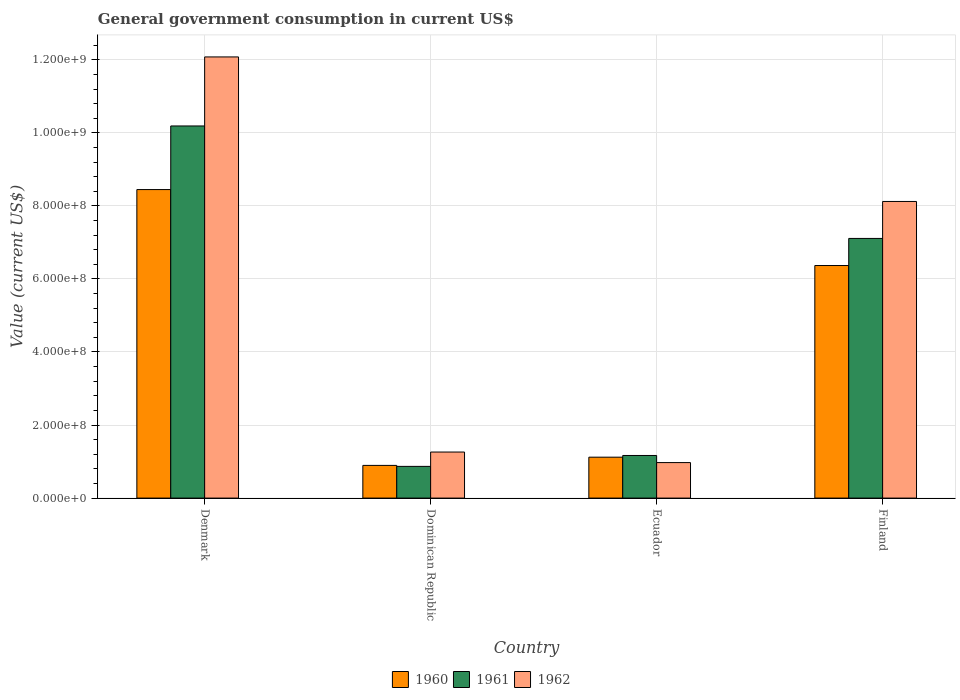How many groups of bars are there?
Your answer should be compact. 4. Are the number of bars on each tick of the X-axis equal?
Your response must be concise. Yes. What is the label of the 1st group of bars from the left?
Make the answer very short. Denmark. In how many cases, is the number of bars for a given country not equal to the number of legend labels?
Make the answer very short. 0. What is the government conusmption in 1960 in Finland?
Make the answer very short. 6.37e+08. Across all countries, what is the maximum government conusmption in 1961?
Ensure brevity in your answer.  1.02e+09. Across all countries, what is the minimum government conusmption in 1960?
Your response must be concise. 8.95e+07. In which country was the government conusmption in 1960 maximum?
Offer a very short reply. Denmark. In which country was the government conusmption in 1960 minimum?
Offer a terse response. Dominican Republic. What is the total government conusmption in 1960 in the graph?
Your answer should be very brief. 1.68e+09. What is the difference between the government conusmption in 1960 in Dominican Republic and that in Finland?
Offer a terse response. -5.47e+08. What is the difference between the government conusmption in 1961 in Ecuador and the government conusmption in 1962 in Dominican Republic?
Give a very brief answer. -9.42e+06. What is the average government conusmption in 1961 per country?
Your answer should be very brief. 4.83e+08. What is the difference between the government conusmption of/in 1960 and government conusmption of/in 1961 in Ecuador?
Give a very brief answer. -4.67e+06. What is the ratio of the government conusmption in 1962 in Denmark to that in Finland?
Make the answer very short. 1.49. Is the government conusmption in 1961 in Denmark less than that in Finland?
Ensure brevity in your answer.  No. What is the difference between the highest and the second highest government conusmption in 1961?
Offer a very short reply. -9.02e+08. What is the difference between the highest and the lowest government conusmption in 1961?
Your answer should be compact. 9.32e+08. In how many countries, is the government conusmption in 1962 greater than the average government conusmption in 1962 taken over all countries?
Your answer should be very brief. 2. Is the sum of the government conusmption in 1960 in Dominican Republic and Finland greater than the maximum government conusmption in 1962 across all countries?
Keep it short and to the point. No. What does the 1st bar from the right in Dominican Republic represents?
Your answer should be very brief. 1962. Is it the case that in every country, the sum of the government conusmption in 1962 and government conusmption in 1961 is greater than the government conusmption in 1960?
Ensure brevity in your answer.  Yes. How many bars are there?
Ensure brevity in your answer.  12. Are all the bars in the graph horizontal?
Provide a short and direct response. No. Does the graph contain any zero values?
Your answer should be compact. No. What is the title of the graph?
Offer a very short reply. General government consumption in current US$. What is the label or title of the X-axis?
Offer a terse response. Country. What is the label or title of the Y-axis?
Offer a terse response. Value (current US$). What is the Value (current US$) of 1960 in Denmark?
Offer a terse response. 8.45e+08. What is the Value (current US$) of 1961 in Denmark?
Make the answer very short. 1.02e+09. What is the Value (current US$) in 1962 in Denmark?
Make the answer very short. 1.21e+09. What is the Value (current US$) of 1960 in Dominican Republic?
Your answer should be very brief. 8.95e+07. What is the Value (current US$) of 1961 in Dominican Republic?
Your answer should be very brief. 8.68e+07. What is the Value (current US$) of 1962 in Dominican Republic?
Provide a succinct answer. 1.26e+08. What is the Value (current US$) in 1960 in Ecuador?
Provide a short and direct response. 1.12e+08. What is the Value (current US$) of 1961 in Ecuador?
Provide a succinct answer. 1.17e+08. What is the Value (current US$) of 1962 in Ecuador?
Make the answer very short. 9.72e+07. What is the Value (current US$) in 1960 in Finland?
Your answer should be very brief. 6.37e+08. What is the Value (current US$) of 1961 in Finland?
Your response must be concise. 7.11e+08. What is the Value (current US$) in 1962 in Finland?
Keep it short and to the point. 8.12e+08. Across all countries, what is the maximum Value (current US$) of 1960?
Make the answer very short. 8.45e+08. Across all countries, what is the maximum Value (current US$) in 1961?
Make the answer very short. 1.02e+09. Across all countries, what is the maximum Value (current US$) in 1962?
Your response must be concise. 1.21e+09. Across all countries, what is the minimum Value (current US$) of 1960?
Give a very brief answer. 8.95e+07. Across all countries, what is the minimum Value (current US$) of 1961?
Provide a short and direct response. 8.68e+07. Across all countries, what is the minimum Value (current US$) of 1962?
Offer a terse response. 9.72e+07. What is the total Value (current US$) in 1960 in the graph?
Ensure brevity in your answer.  1.68e+09. What is the total Value (current US$) in 1961 in the graph?
Your answer should be compact. 1.93e+09. What is the total Value (current US$) of 1962 in the graph?
Offer a very short reply. 2.24e+09. What is the difference between the Value (current US$) in 1960 in Denmark and that in Dominican Republic?
Keep it short and to the point. 7.55e+08. What is the difference between the Value (current US$) in 1961 in Denmark and that in Dominican Republic?
Provide a succinct answer. 9.32e+08. What is the difference between the Value (current US$) of 1962 in Denmark and that in Dominican Republic?
Provide a short and direct response. 1.08e+09. What is the difference between the Value (current US$) of 1960 in Denmark and that in Ecuador?
Make the answer very short. 7.33e+08. What is the difference between the Value (current US$) of 1961 in Denmark and that in Ecuador?
Your answer should be compact. 9.02e+08. What is the difference between the Value (current US$) in 1962 in Denmark and that in Ecuador?
Provide a short and direct response. 1.11e+09. What is the difference between the Value (current US$) in 1960 in Denmark and that in Finland?
Offer a terse response. 2.08e+08. What is the difference between the Value (current US$) in 1961 in Denmark and that in Finland?
Ensure brevity in your answer.  3.08e+08. What is the difference between the Value (current US$) of 1962 in Denmark and that in Finland?
Offer a very short reply. 3.96e+08. What is the difference between the Value (current US$) of 1960 in Dominican Republic and that in Ecuador?
Keep it short and to the point. -2.25e+07. What is the difference between the Value (current US$) of 1961 in Dominican Republic and that in Ecuador?
Keep it short and to the point. -2.99e+07. What is the difference between the Value (current US$) of 1962 in Dominican Republic and that in Ecuador?
Make the answer very short. 2.89e+07. What is the difference between the Value (current US$) of 1960 in Dominican Republic and that in Finland?
Give a very brief answer. -5.47e+08. What is the difference between the Value (current US$) of 1961 in Dominican Republic and that in Finland?
Make the answer very short. -6.24e+08. What is the difference between the Value (current US$) in 1962 in Dominican Republic and that in Finland?
Offer a terse response. -6.86e+08. What is the difference between the Value (current US$) in 1960 in Ecuador and that in Finland?
Provide a short and direct response. -5.25e+08. What is the difference between the Value (current US$) in 1961 in Ecuador and that in Finland?
Provide a short and direct response. -5.94e+08. What is the difference between the Value (current US$) in 1962 in Ecuador and that in Finland?
Keep it short and to the point. -7.15e+08. What is the difference between the Value (current US$) in 1960 in Denmark and the Value (current US$) in 1961 in Dominican Republic?
Keep it short and to the point. 7.58e+08. What is the difference between the Value (current US$) in 1960 in Denmark and the Value (current US$) in 1962 in Dominican Republic?
Your answer should be compact. 7.19e+08. What is the difference between the Value (current US$) in 1961 in Denmark and the Value (current US$) in 1962 in Dominican Republic?
Give a very brief answer. 8.93e+08. What is the difference between the Value (current US$) of 1960 in Denmark and the Value (current US$) of 1961 in Ecuador?
Provide a short and direct response. 7.28e+08. What is the difference between the Value (current US$) of 1960 in Denmark and the Value (current US$) of 1962 in Ecuador?
Keep it short and to the point. 7.47e+08. What is the difference between the Value (current US$) of 1961 in Denmark and the Value (current US$) of 1962 in Ecuador?
Your response must be concise. 9.22e+08. What is the difference between the Value (current US$) in 1960 in Denmark and the Value (current US$) in 1961 in Finland?
Keep it short and to the point. 1.34e+08. What is the difference between the Value (current US$) of 1960 in Denmark and the Value (current US$) of 1962 in Finland?
Ensure brevity in your answer.  3.25e+07. What is the difference between the Value (current US$) of 1961 in Denmark and the Value (current US$) of 1962 in Finland?
Your answer should be compact. 2.07e+08. What is the difference between the Value (current US$) of 1960 in Dominican Republic and the Value (current US$) of 1961 in Ecuador?
Ensure brevity in your answer.  -2.72e+07. What is the difference between the Value (current US$) of 1960 in Dominican Republic and the Value (current US$) of 1962 in Ecuador?
Your response must be concise. -7.73e+06. What is the difference between the Value (current US$) in 1961 in Dominican Republic and the Value (current US$) in 1962 in Ecuador?
Make the answer very short. -1.04e+07. What is the difference between the Value (current US$) of 1960 in Dominican Republic and the Value (current US$) of 1961 in Finland?
Offer a terse response. -6.21e+08. What is the difference between the Value (current US$) of 1960 in Dominican Republic and the Value (current US$) of 1962 in Finland?
Keep it short and to the point. -7.23e+08. What is the difference between the Value (current US$) of 1961 in Dominican Republic and the Value (current US$) of 1962 in Finland?
Your answer should be compact. -7.25e+08. What is the difference between the Value (current US$) of 1960 in Ecuador and the Value (current US$) of 1961 in Finland?
Make the answer very short. -5.99e+08. What is the difference between the Value (current US$) in 1960 in Ecuador and the Value (current US$) in 1962 in Finland?
Provide a succinct answer. -7.00e+08. What is the difference between the Value (current US$) of 1961 in Ecuador and the Value (current US$) of 1962 in Finland?
Make the answer very short. -6.95e+08. What is the average Value (current US$) in 1960 per country?
Your response must be concise. 4.21e+08. What is the average Value (current US$) in 1961 per country?
Your answer should be very brief. 4.83e+08. What is the average Value (current US$) of 1962 per country?
Your response must be concise. 5.61e+08. What is the difference between the Value (current US$) of 1960 and Value (current US$) of 1961 in Denmark?
Make the answer very short. -1.74e+08. What is the difference between the Value (current US$) of 1960 and Value (current US$) of 1962 in Denmark?
Make the answer very short. -3.63e+08. What is the difference between the Value (current US$) in 1961 and Value (current US$) in 1962 in Denmark?
Provide a succinct answer. -1.89e+08. What is the difference between the Value (current US$) of 1960 and Value (current US$) of 1961 in Dominican Republic?
Offer a very short reply. 2.70e+06. What is the difference between the Value (current US$) in 1960 and Value (current US$) in 1962 in Dominican Republic?
Ensure brevity in your answer.  -3.66e+07. What is the difference between the Value (current US$) of 1961 and Value (current US$) of 1962 in Dominican Republic?
Your answer should be compact. -3.93e+07. What is the difference between the Value (current US$) of 1960 and Value (current US$) of 1961 in Ecuador?
Offer a terse response. -4.67e+06. What is the difference between the Value (current US$) in 1960 and Value (current US$) in 1962 in Ecuador?
Give a very brief answer. 1.48e+07. What is the difference between the Value (current US$) in 1961 and Value (current US$) in 1962 in Ecuador?
Provide a succinct answer. 1.94e+07. What is the difference between the Value (current US$) in 1960 and Value (current US$) in 1961 in Finland?
Provide a succinct answer. -7.42e+07. What is the difference between the Value (current US$) in 1960 and Value (current US$) in 1962 in Finland?
Offer a terse response. -1.75e+08. What is the difference between the Value (current US$) of 1961 and Value (current US$) of 1962 in Finland?
Your answer should be compact. -1.01e+08. What is the ratio of the Value (current US$) of 1960 in Denmark to that in Dominican Republic?
Make the answer very short. 9.44. What is the ratio of the Value (current US$) of 1961 in Denmark to that in Dominican Republic?
Give a very brief answer. 11.74. What is the ratio of the Value (current US$) of 1962 in Denmark to that in Dominican Republic?
Make the answer very short. 9.58. What is the ratio of the Value (current US$) of 1960 in Denmark to that in Ecuador?
Ensure brevity in your answer.  7.54. What is the ratio of the Value (current US$) of 1961 in Denmark to that in Ecuador?
Provide a short and direct response. 8.73. What is the ratio of the Value (current US$) of 1962 in Denmark to that in Ecuador?
Ensure brevity in your answer.  12.42. What is the ratio of the Value (current US$) of 1960 in Denmark to that in Finland?
Ensure brevity in your answer.  1.33. What is the ratio of the Value (current US$) of 1961 in Denmark to that in Finland?
Make the answer very short. 1.43. What is the ratio of the Value (current US$) in 1962 in Denmark to that in Finland?
Your answer should be very brief. 1.49. What is the ratio of the Value (current US$) of 1960 in Dominican Republic to that in Ecuador?
Keep it short and to the point. 0.8. What is the ratio of the Value (current US$) of 1961 in Dominican Republic to that in Ecuador?
Keep it short and to the point. 0.74. What is the ratio of the Value (current US$) in 1962 in Dominican Republic to that in Ecuador?
Make the answer very short. 1.3. What is the ratio of the Value (current US$) in 1960 in Dominican Republic to that in Finland?
Provide a short and direct response. 0.14. What is the ratio of the Value (current US$) of 1961 in Dominican Republic to that in Finland?
Offer a very short reply. 0.12. What is the ratio of the Value (current US$) of 1962 in Dominican Republic to that in Finland?
Your answer should be compact. 0.16. What is the ratio of the Value (current US$) of 1960 in Ecuador to that in Finland?
Your answer should be compact. 0.18. What is the ratio of the Value (current US$) in 1961 in Ecuador to that in Finland?
Offer a terse response. 0.16. What is the ratio of the Value (current US$) of 1962 in Ecuador to that in Finland?
Give a very brief answer. 0.12. What is the difference between the highest and the second highest Value (current US$) of 1960?
Offer a terse response. 2.08e+08. What is the difference between the highest and the second highest Value (current US$) of 1961?
Your answer should be very brief. 3.08e+08. What is the difference between the highest and the second highest Value (current US$) of 1962?
Offer a very short reply. 3.96e+08. What is the difference between the highest and the lowest Value (current US$) of 1960?
Provide a short and direct response. 7.55e+08. What is the difference between the highest and the lowest Value (current US$) in 1961?
Ensure brevity in your answer.  9.32e+08. What is the difference between the highest and the lowest Value (current US$) of 1962?
Provide a short and direct response. 1.11e+09. 